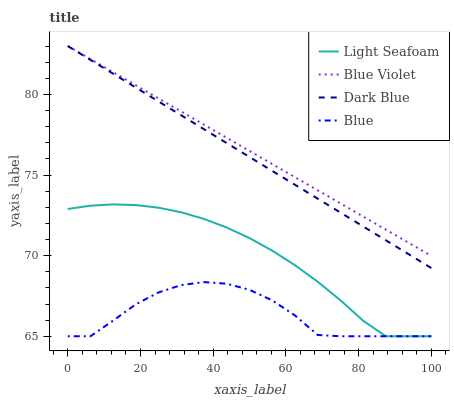Does Blue have the minimum area under the curve?
Answer yes or no. Yes. Does Blue Violet have the maximum area under the curve?
Answer yes or no. Yes. Does Dark Blue have the minimum area under the curve?
Answer yes or no. No. Does Dark Blue have the maximum area under the curve?
Answer yes or no. No. Is Dark Blue the smoothest?
Answer yes or no. Yes. Is Blue the roughest?
Answer yes or no. Yes. Is Light Seafoam the smoothest?
Answer yes or no. No. Is Light Seafoam the roughest?
Answer yes or no. No. Does Blue have the lowest value?
Answer yes or no. Yes. Does Dark Blue have the lowest value?
Answer yes or no. No. Does Blue Violet have the highest value?
Answer yes or no. Yes. Does Light Seafoam have the highest value?
Answer yes or no. No. Is Light Seafoam less than Blue Violet?
Answer yes or no. Yes. Is Blue Violet greater than Blue?
Answer yes or no. Yes. Does Blue Violet intersect Dark Blue?
Answer yes or no. Yes. Is Blue Violet less than Dark Blue?
Answer yes or no. No. Is Blue Violet greater than Dark Blue?
Answer yes or no. No. Does Light Seafoam intersect Blue Violet?
Answer yes or no. No. 